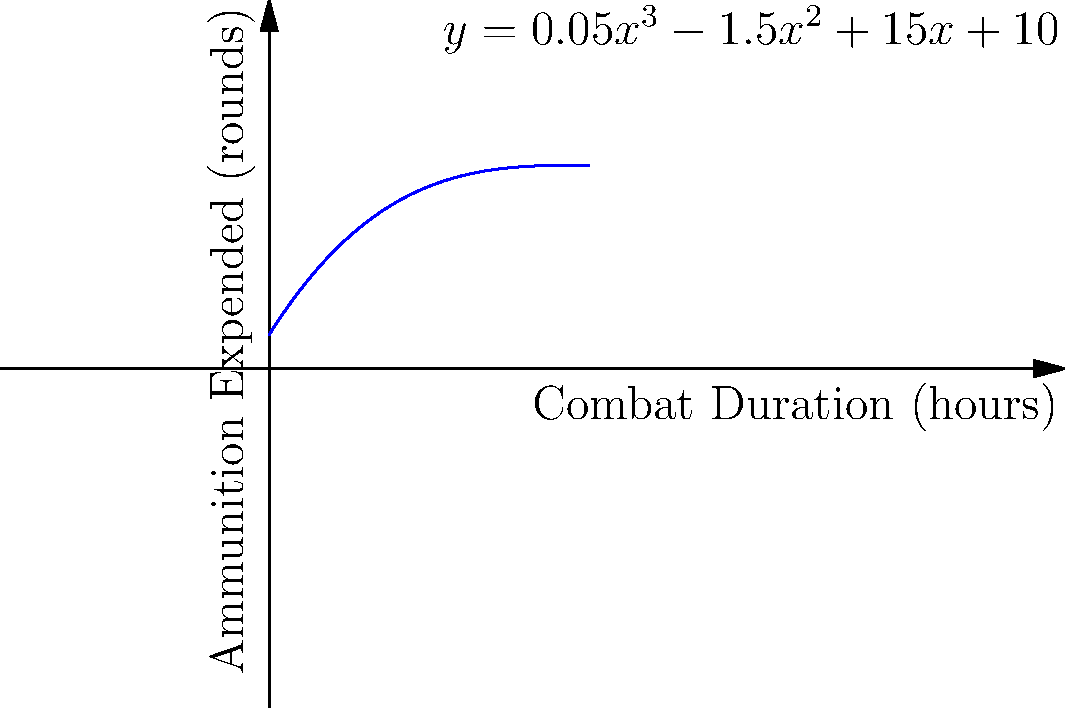In a recent combat scenario, ammunition expenditure was modeled using the polynomial function $y = 0.05x^3 - 1.5x^2 + 15x + 10$, where $y$ represents rounds of ammunition expended and $x$ represents combat duration in hours. At what point during the engagement does the rate of ammunition expenditure reach its minimum? To find the point where the rate of ammunition expenditure reaches its minimum:

1. The rate of ammunition expenditure is represented by the first derivative of the given function:
   $y' = 0.15x^2 - 3x + 15$

2. The minimum rate occurs where the second derivative equals zero:
   $y'' = 0.3x - 3 = 0$

3. Solve for x:
   $0.3x = 3$
   $x = 10$

4. Verify it's a minimum by checking if $y''(10) > 0$:
   $y''(10) = 0.3(10) - 3 = 0 > 0$

5. Calculate the corresponding y-value:
   $y = 0.05(10)^3 - 1.5(10)^2 + 15(10) + 10$
   $y = 50 - 150 + 150 + 10 = 60$

Therefore, the rate of ammunition expenditure reaches its minimum at 10 hours into the combat, when 60 rounds have been expended.
Answer: 10 hours 